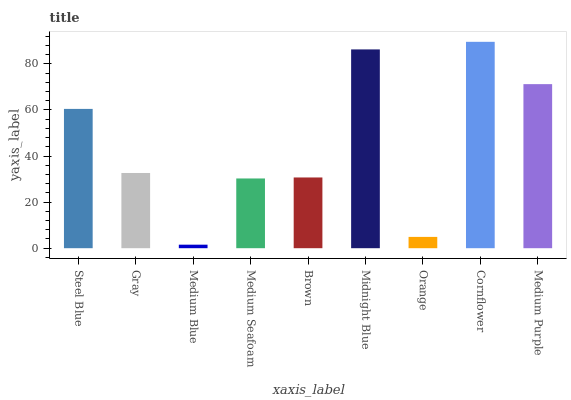Is Gray the minimum?
Answer yes or no. No. Is Gray the maximum?
Answer yes or no. No. Is Steel Blue greater than Gray?
Answer yes or no. Yes. Is Gray less than Steel Blue?
Answer yes or no. Yes. Is Gray greater than Steel Blue?
Answer yes or no. No. Is Steel Blue less than Gray?
Answer yes or no. No. Is Gray the high median?
Answer yes or no. Yes. Is Gray the low median?
Answer yes or no. Yes. Is Cornflower the high median?
Answer yes or no. No. Is Orange the low median?
Answer yes or no. No. 